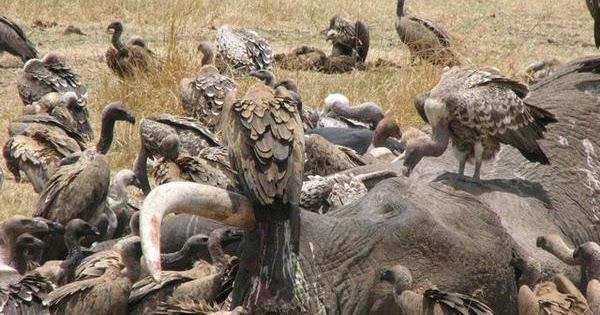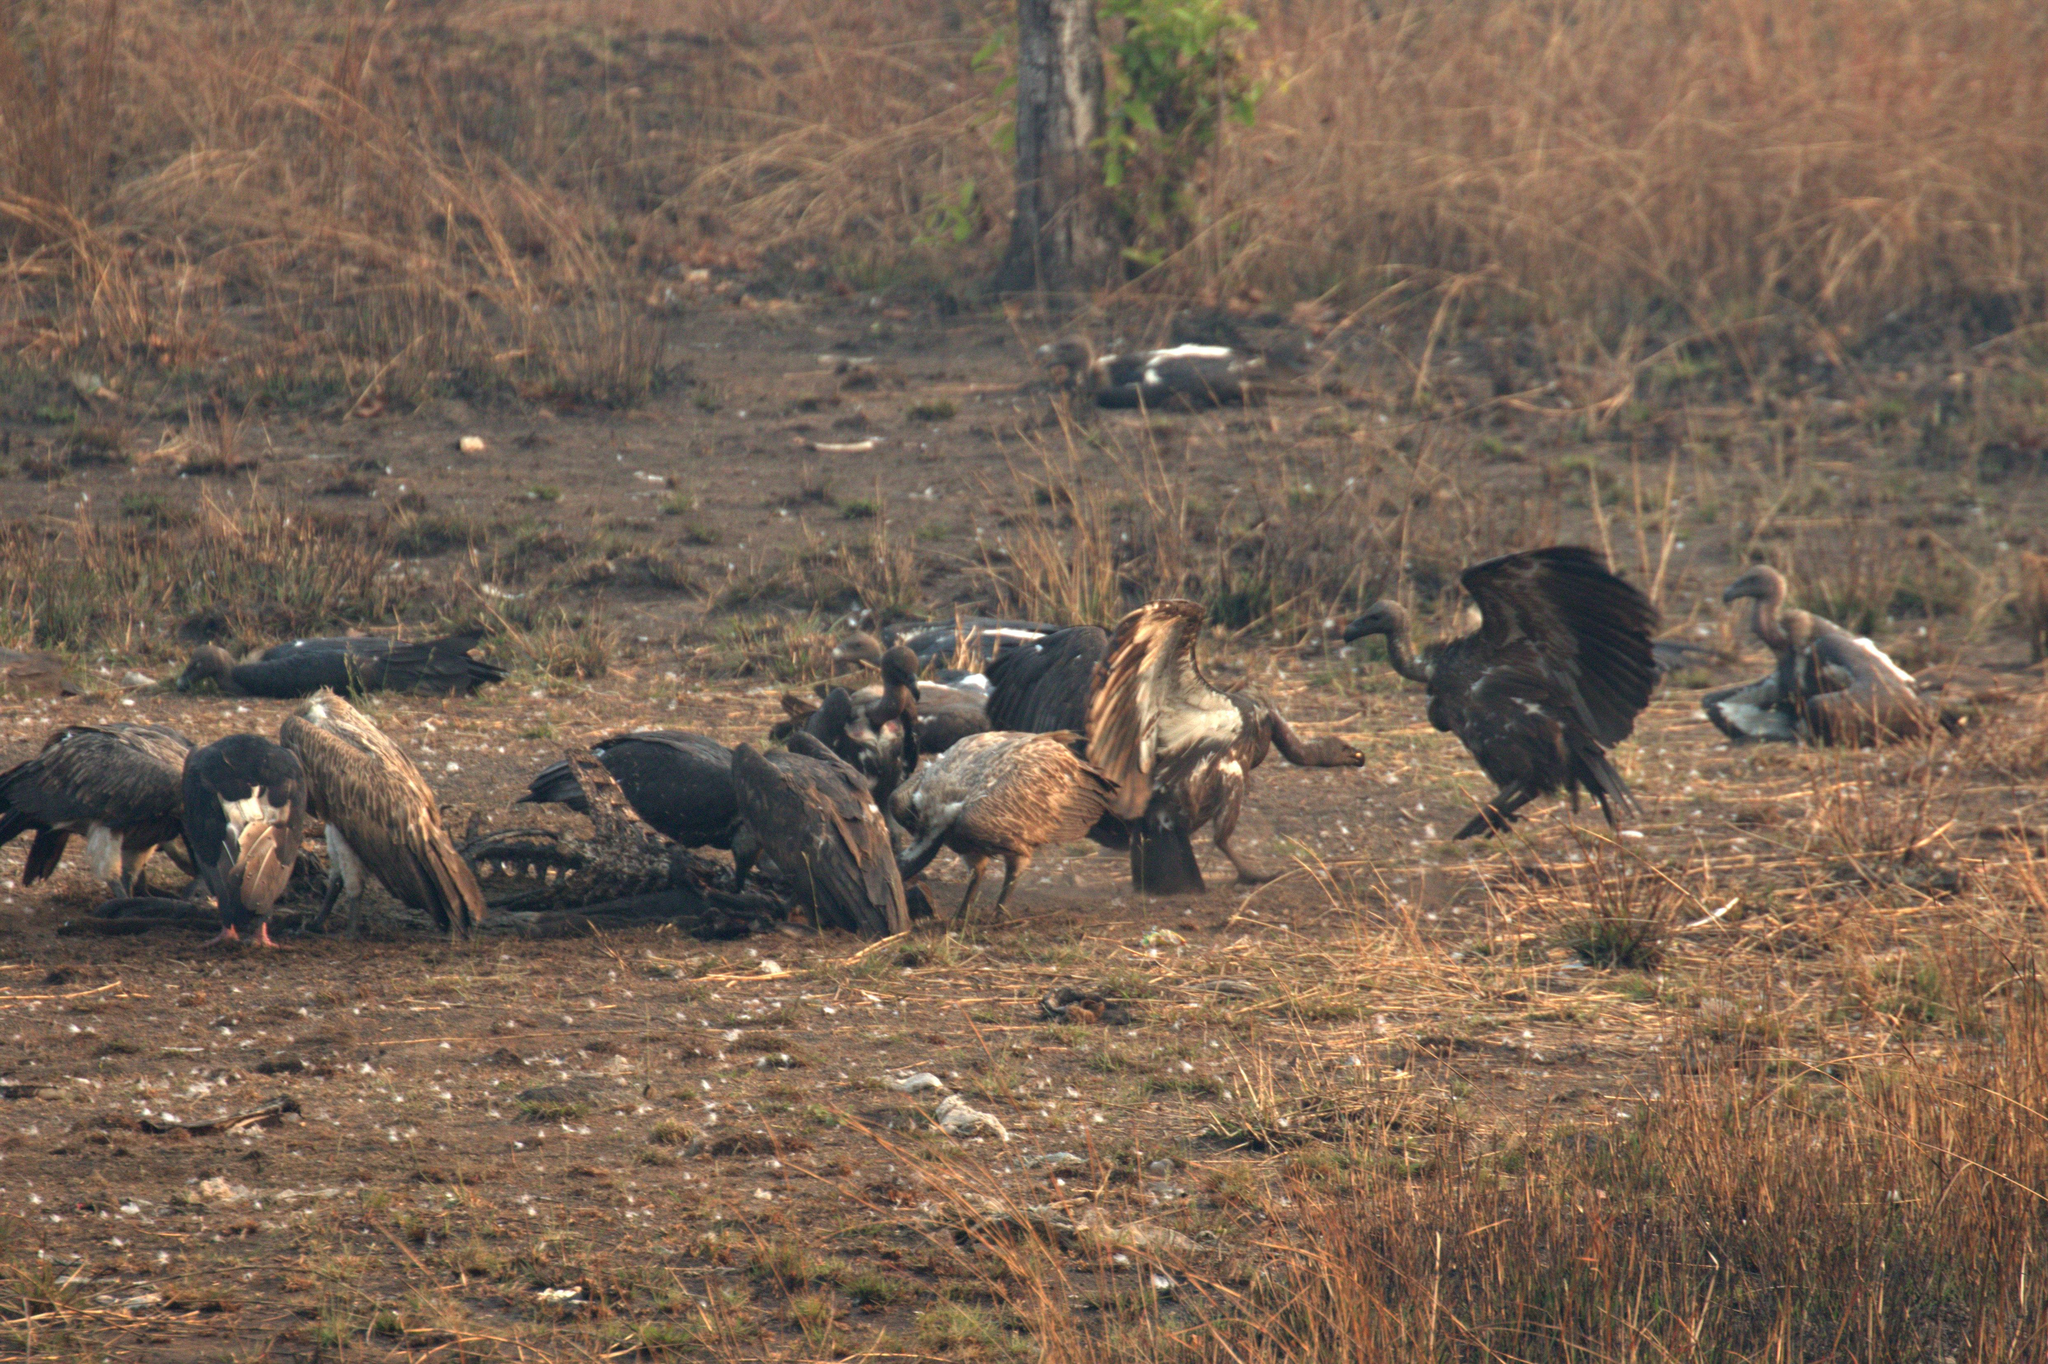The first image is the image on the left, the second image is the image on the right. Assess this claim about the two images: "There are a total of two hyena in the images.". Correct or not? Answer yes or no. No. The first image is the image on the left, the second image is the image on the right. Considering the images on both sides, is "there is at least one hyena in the image on the left" valid? Answer yes or no. No. 